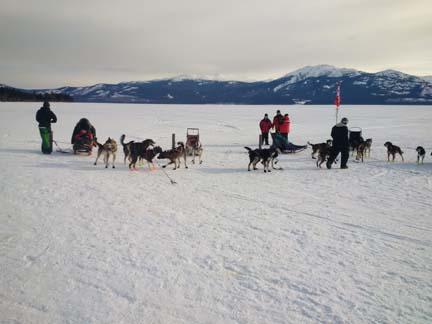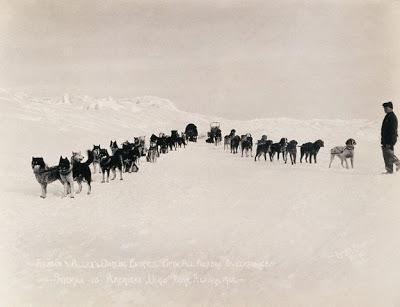The first image is the image on the left, the second image is the image on the right. Given the left and right images, does the statement "In the image to the right, the lead dog is a white husky." hold true? Answer yes or no. No. The first image is the image on the left, the second image is the image on the right. For the images displayed, is the sentence "The left image contains only one sled, which is wooden and hitched to at least one leftward-turned dog with a person standing by the dog." factually correct? Answer yes or no. No. 